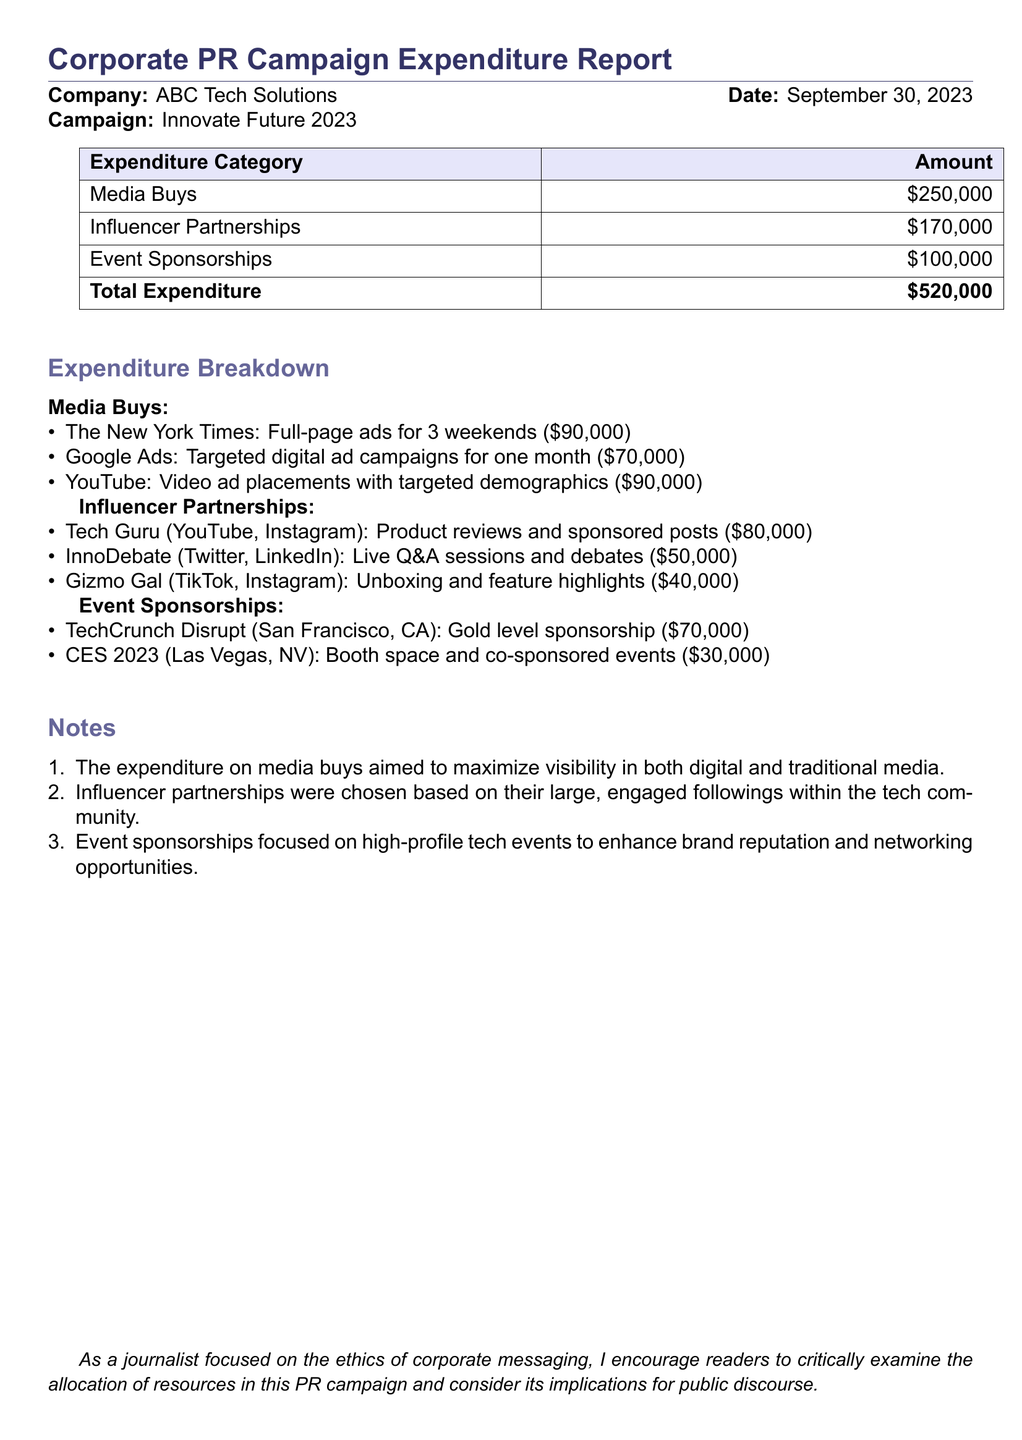What is the total expenditure of the campaign? The total expenditure is the sum of all expenditure categories mentioned in the document, which totals to $250,000 + $170,000 + $100,000 = $520,000.
Answer: $520,000 How much was spent on media buys? The expenditure category for media buys is clearly stated as $250,000 in the document.
Answer: $250,000 What influencer partnership cost the most? Among the listed influencer partnerships, Tech Guru had the highest expenditure at $80,000.
Answer: Tech Guru What was the expenditure on event sponsorships? The total amount spent on event sponsorships is specifically listed as $100,000 in the document.
Answer: $100,000 Which media platform had the highest ad spend? The breakdown shows that YouTube had the highest expenditure for media buys at $90,000.
Answer: YouTube How many influencers were partnered with in total? The document lists three influencer partnerships under the influencer category.
Answer: Three What was the cost of the TechCrunch Disrupt sponsorship? The document specifies that the sponsorship for TechCrunch Disrupt cost $70,000.
Answer: $70,000 What is the primary objective of the media buys according to the notes? The notes indicate that the media buys aimed to maximize visibility in both digital and traditional media.
Answer: Maximize visibility What type of events were prioritized for sponsorships? The document states that sponsorships focused on high-profile tech events.
Answer: High-profile tech events What was the total cost for influencer partnerships? The combined cost for the three influencer partnerships is $80,000 + $50,000 + $40,000 = $170,000, as provided in the breakdown.
Answer: $170,000 